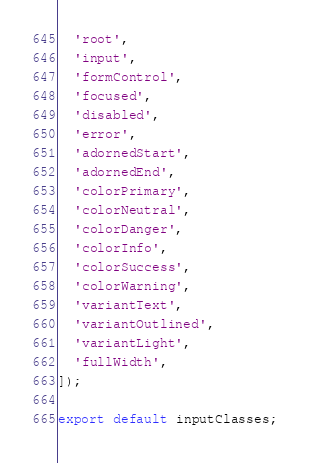<code> <loc_0><loc_0><loc_500><loc_500><_TypeScript_>  'root',
  'input',
  'formControl',
  'focused',
  'disabled',
  'error',
  'adornedStart',
  'adornedEnd',
  'colorPrimary',
  'colorNeutral',
  'colorDanger',
  'colorInfo',
  'colorSuccess',
  'colorWarning',
  'variantText',
  'variantOutlined',
  'variantLight',
  'fullWidth',
]);

export default inputClasses;
</code> 